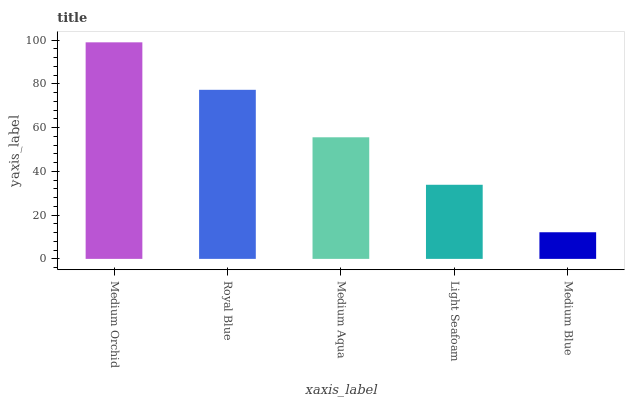Is Medium Blue the minimum?
Answer yes or no. Yes. Is Medium Orchid the maximum?
Answer yes or no. Yes. Is Royal Blue the minimum?
Answer yes or no. No. Is Royal Blue the maximum?
Answer yes or no. No. Is Medium Orchid greater than Royal Blue?
Answer yes or no. Yes. Is Royal Blue less than Medium Orchid?
Answer yes or no. Yes. Is Royal Blue greater than Medium Orchid?
Answer yes or no. No. Is Medium Orchid less than Royal Blue?
Answer yes or no. No. Is Medium Aqua the high median?
Answer yes or no. Yes. Is Medium Aqua the low median?
Answer yes or no. Yes. Is Medium Blue the high median?
Answer yes or no. No. Is Medium Orchid the low median?
Answer yes or no. No. 